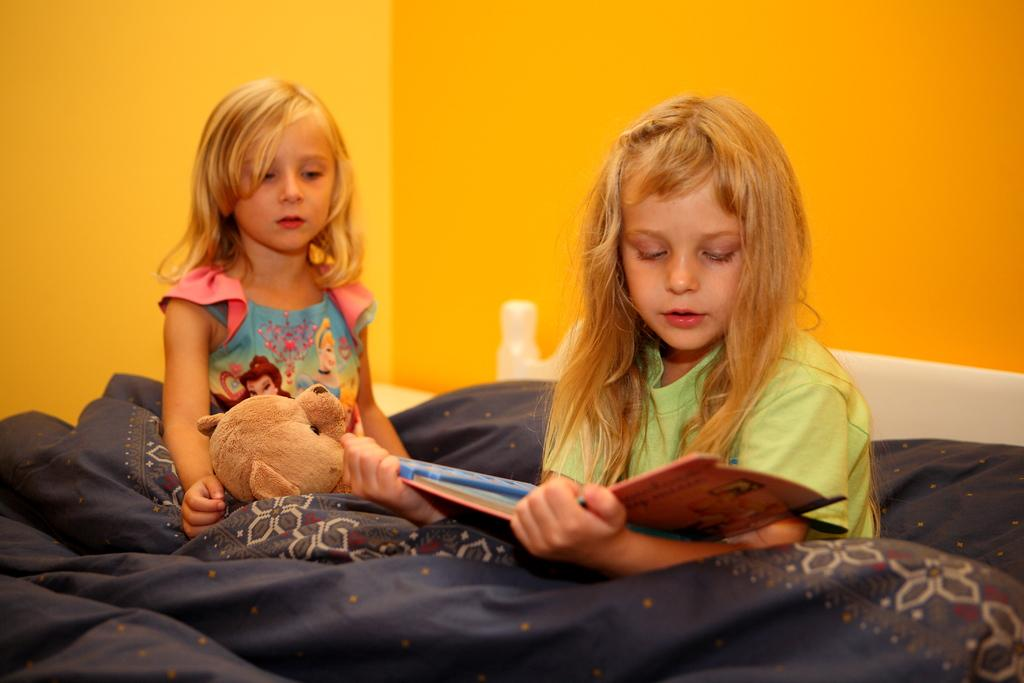How many people are in the image? There are two girls in the image. What are the girls doing in the image? The girls are sitting on a bed. What can be seen in the background of the image? There is a wall in the background of the image. Can you see any feathers floating around the girls in the image? No, there are no feathers visible in the image. Are the girls at the airport in the image? No, there is no indication of an airport in the image. 